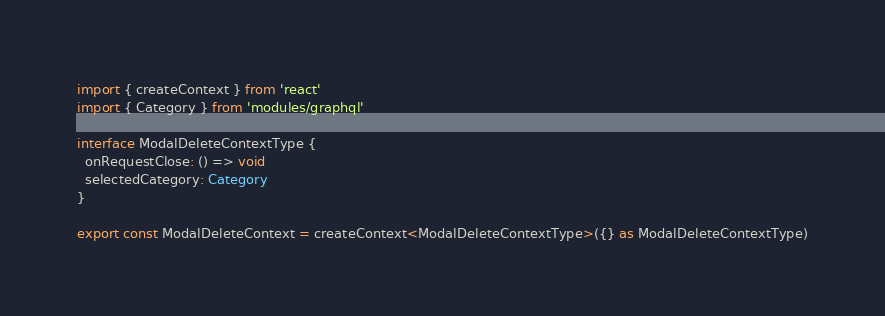Convert code to text. <code><loc_0><loc_0><loc_500><loc_500><_TypeScript_>import { createContext } from 'react'
import { Category } from 'modules/graphql'

interface ModalDeleteContextType {
  onRequestClose: () => void
  selectedCategory: Category
}

export const ModalDeleteContext = createContext<ModalDeleteContextType>({} as ModalDeleteContextType)
</code> 